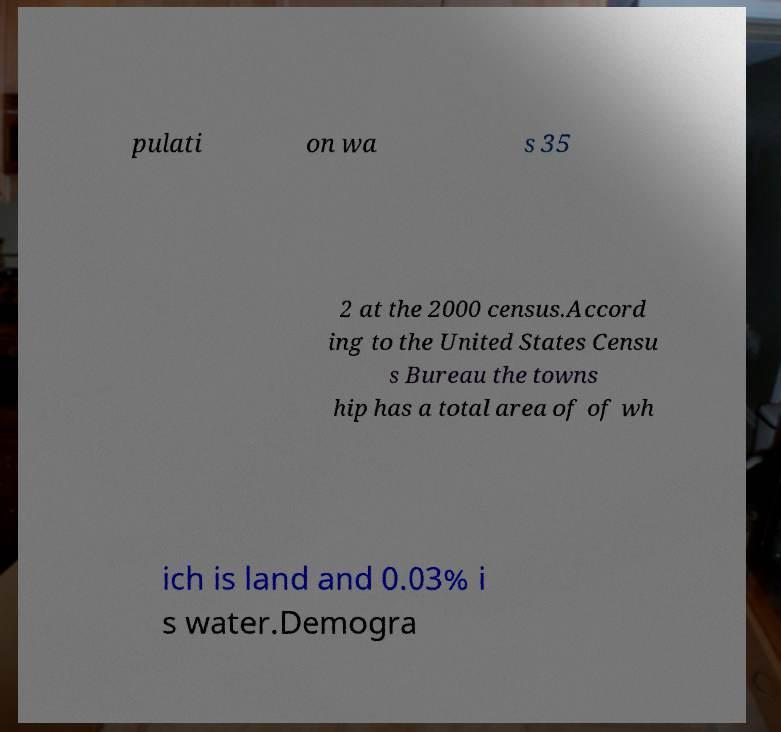Could you assist in decoding the text presented in this image and type it out clearly? pulati on wa s 35 2 at the 2000 census.Accord ing to the United States Censu s Bureau the towns hip has a total area of of wh ich is land and 0.03% i s water.Demogra 